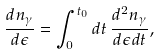<formula> <loc_0><loc_0><loc_500><loc_500>\frac { d n _ { \gamma } } { d \epsilon } = \int _ { 0 } ^ { t _ { 0 } } d t \, \frac { d ^ { 2 } n _ { \gamma } } { d \epsilon d t } ,</formula> 